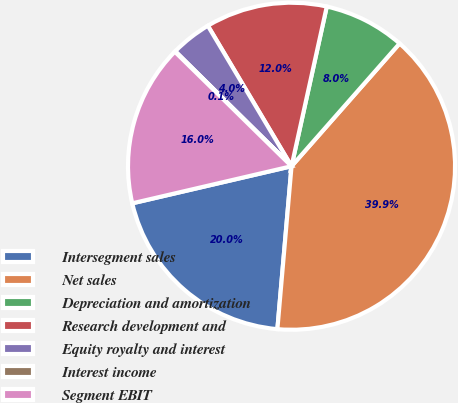<chart> <loc_0><loc_0><loc_500><loc_500><pie_chart><fcel>Intersegment sales<fcel>Net sales<fcel>Depreciation and amortization<fcel>Research development and<fcel>Equity royalty and interest<fcel>Interest income<fcel>Segment EBIT<nl><fcel>19.98%<fcel>39.89%<fcel>8.03%<fcel>12.01%<fcel>4.04%<fcel>0.06%<fcel>15.99%<nl></chart> 